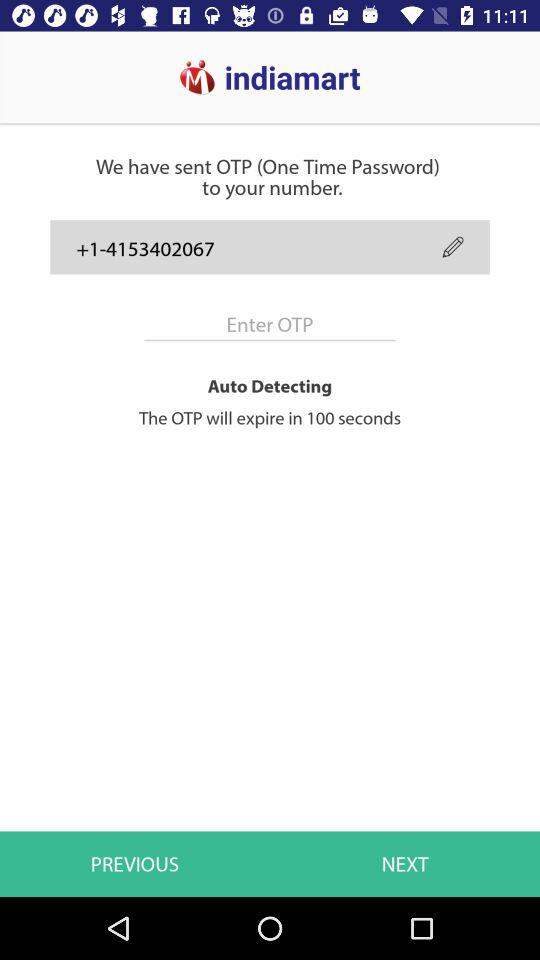What is the application name? The application name is "indiamart". 